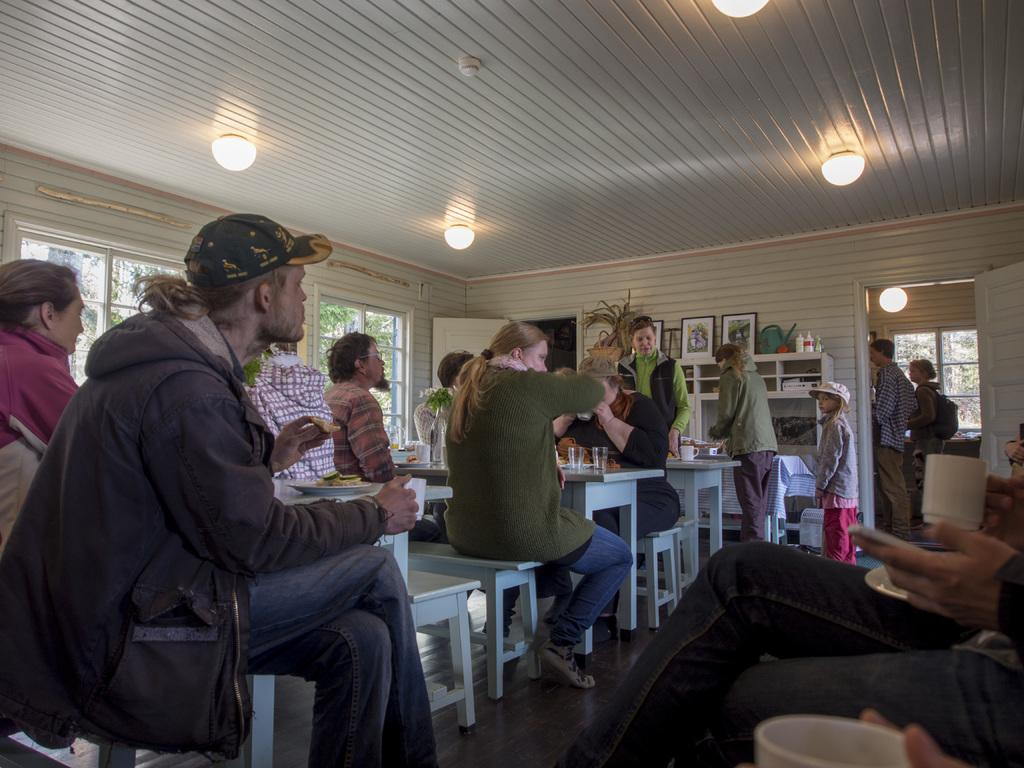How many people are in the image? There is a group of persons in the image, but the exact number is not specified. What are the persons doing in the image? The persons are sitting on a white bench. What can be seen in front of the group of persons? There are eatables in front of the group of persons. What type of fork can be seen in the image? There is no fork present in the image. Is there a volcano visible in the background of the image? There is no mention of a volcano or any background in the provided facts, so it cannot be determined from the image. 